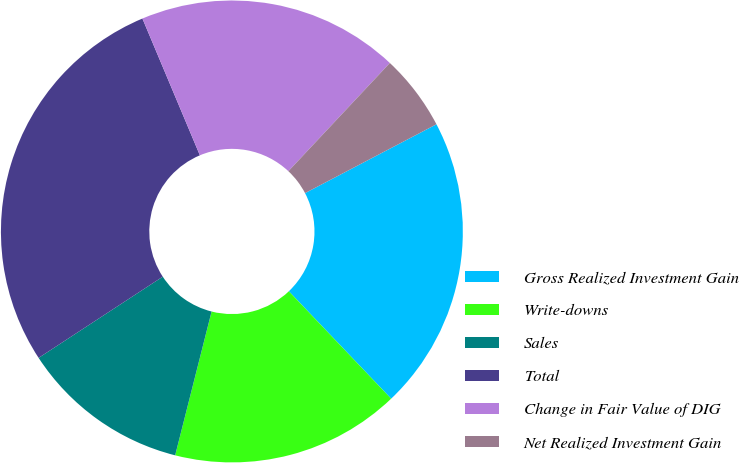<chart> <loc_0><loc_0><loc_500><loc_500><pie_chart><fcel>Gross Realized Investment Gain<fcel>Write-downs<fcel>Sales<fcel>Total<fcel>Change in Fair Value of DIG<fcel>Net Realized Investment Gain<nl><fcel>20.57%<fcel>16.06%<fcel>11.83%<fcel>27.89%<fcel>18.32%<fcel>5.33%<nl></chart> 